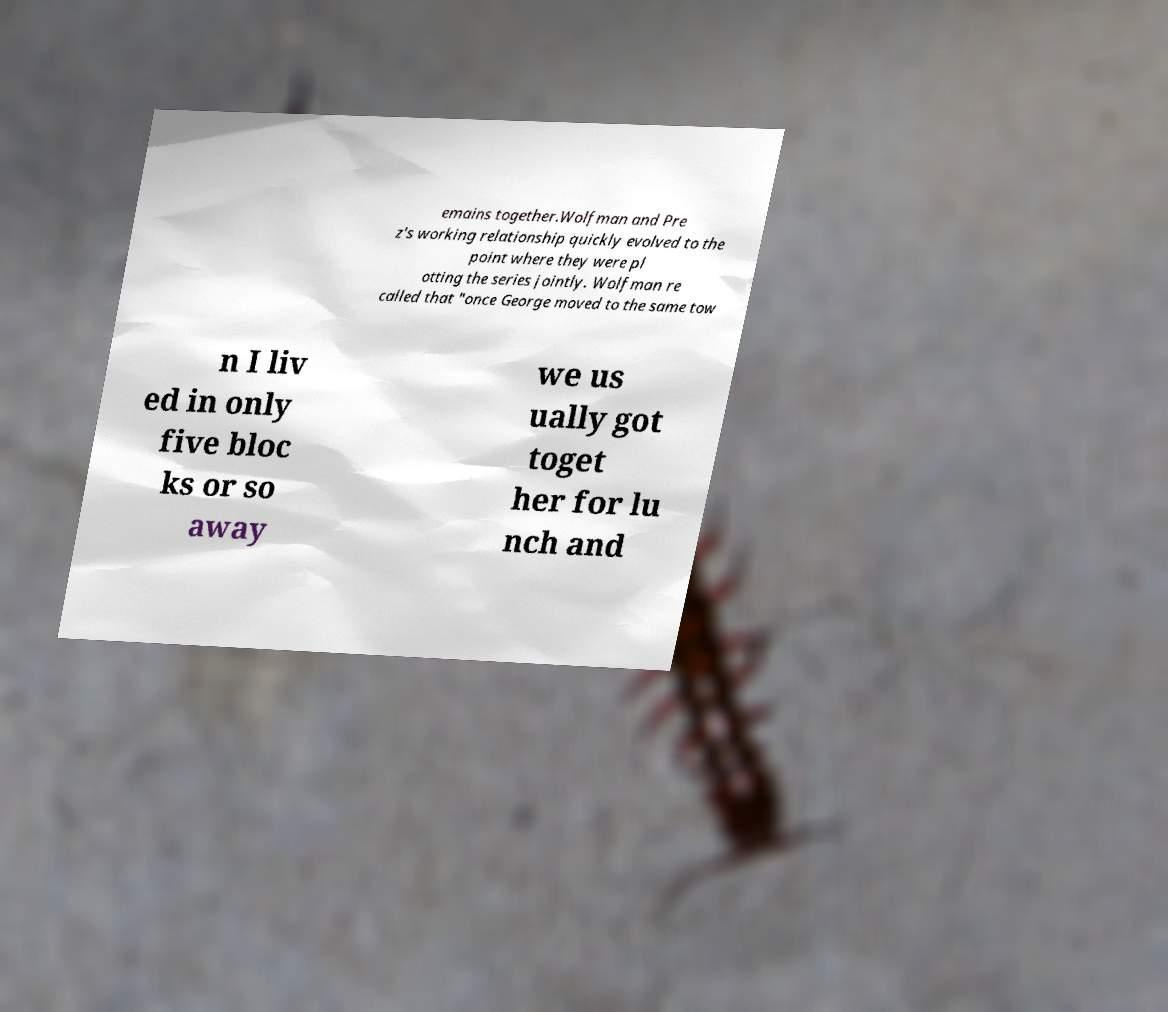Can you read and provide the text displayed in the image?This photo seems to have some interesting text. Can you extract and type it out for me? emains together.Wolfman and Pre z's working relationship quickly evolved to the point where they were pl otting the series jointly. Wolfman re called that "once George moved to the same tow n I liv ed in only five bloc ks or so away we us ually got toget her for lu nch and 